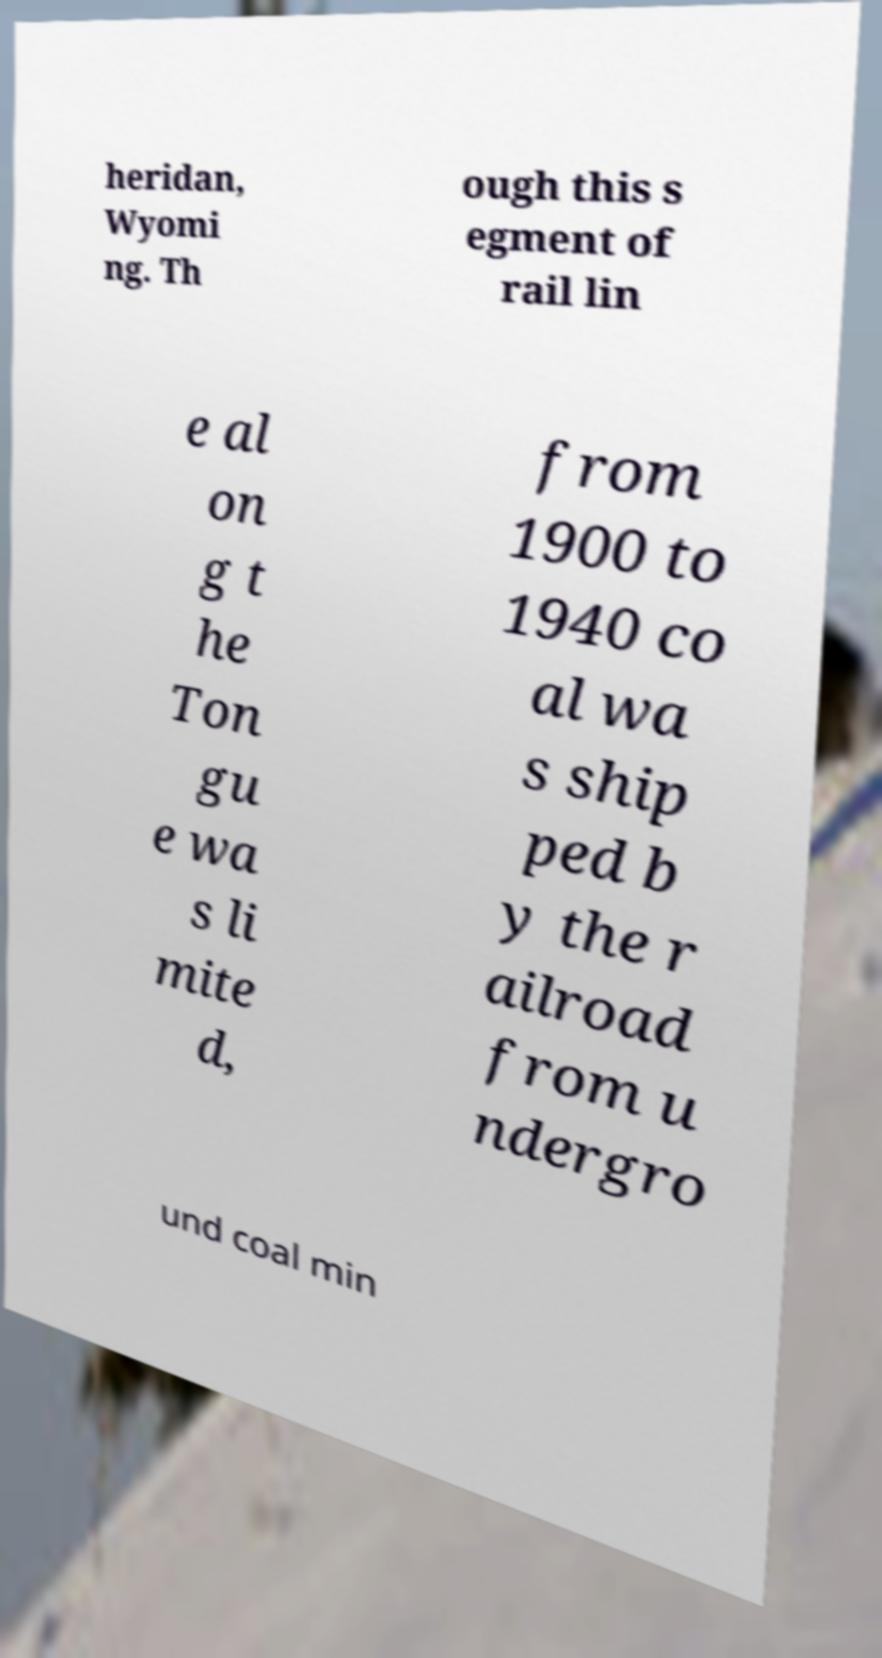Can you read and provide the text displayed in the image?This photo seems to have some interesting text. Can you extract and type it out for me? heridan, Wyomi ng. Th ough this s egment of rail lin e al on g t he Ton gu e wa s li mite d, from 1900 to 1940 co al wa s ship ped b y the r ailroad from u ndergro und coal min 